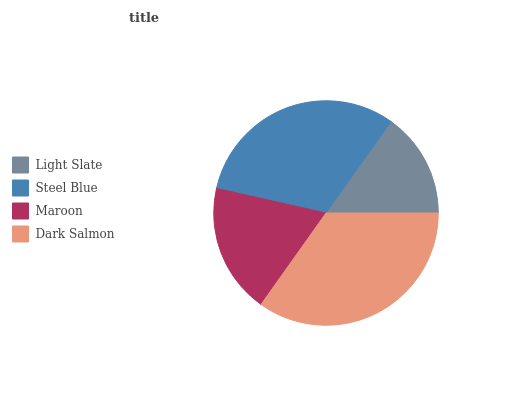Is Light Slate the minimum?
Answer yes or no. Yes. Is Dark Salmon the maximum?
Answer yes or no. Yes. Is Steel Blue the minimum?
Answer yes or no. No. Is Steel Blue the maximum?
Answer yes or no. No. Is Steel Blue greater than Light Slate?
Answer yes or no. Yes. Is Light Slate less than Steel Blue?
Answer yes or no. Yes. Is Light Slate greater than Steel Blue?
Answer yes or no. No. Is Steel Blue less than Light Slate?
Answer yes or no. No. Is Steel Blue the high median?
Answer yes or no. Yes. Is Maroon the low median?
Answer yes or no. Yes. Is Maroon the high median?
Answer yes or no. No. Is Steel Blue the low median?
Answer yes or no. No. 